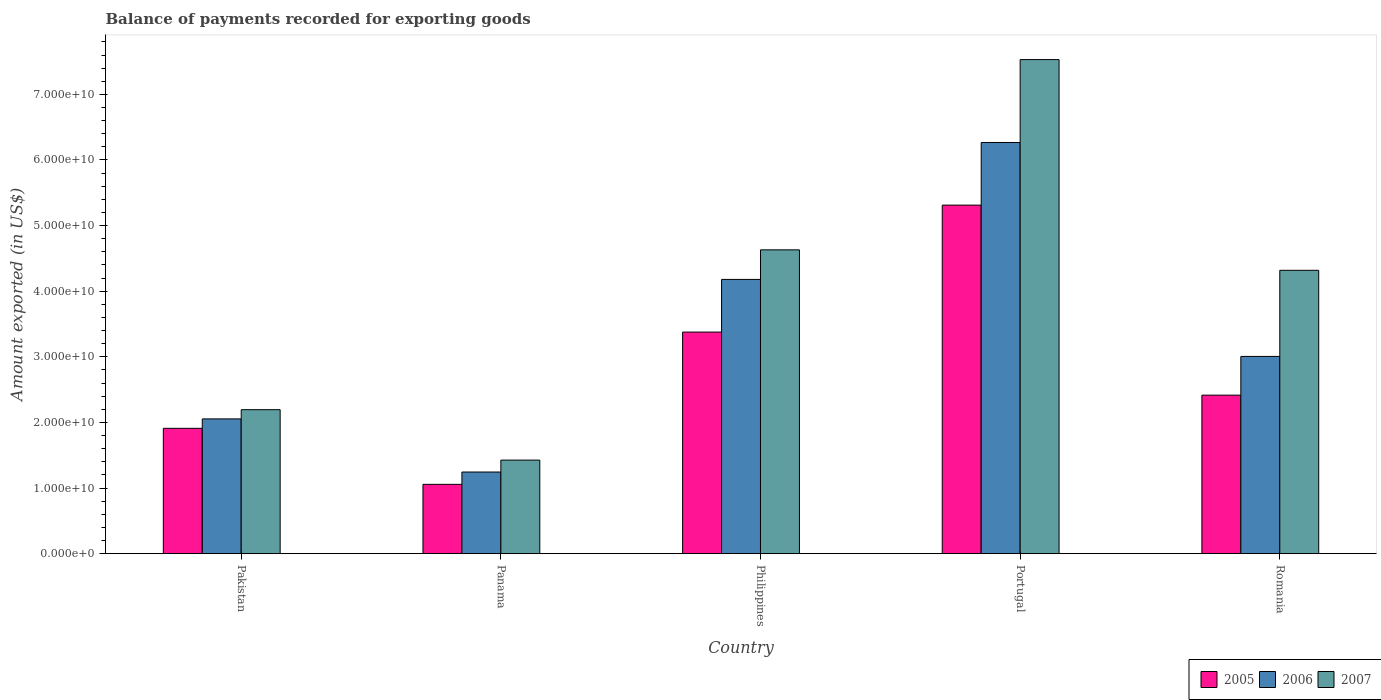How many different coloured bars are there?
Your answer should be very brief. 3. How many groups of bars are there?
Your answer should be compact. 5. Are the number of bars per tick equal to the number of legend labels?
Make the answer very short. Yes. Are the number of bars on each tick of the X-axis equal?
Provide a succinct answer. Yes. What is the label of the 3rd group of bars from the left?
Provide a succinct answer. Philippines. What is the amount exported in 2007 in Romania?
Offer a very short reply. 4.32e+1. Across all countries, what is the maximum amount exported in 2007?
Your answer should be very brief. 7.53e+1. Across all countries, what is the minimum amount exported in 2006?
Provide a short and direct response. 1.24e+1. In which country was the amount exported in 2005 minimum?
Give a very brief answer. Panama. What is the total amount exported in 2006 in the graph?
Your answer should be very brief. 1.68e+11. What is the difference between the amount exported in 2006 in Philippines and that in Portugal?
Your answer should be compact. -2.09e+1. What is the difference between the amount exported in 2006 in Romania and the amount exported in 2007 in Panama?
Your answer should be compact. 1.58e+1. What is the average amount exported in 2005 per country?
Offer a very short reply. 2.81e+1. What is the difference between the amount exported of/in 2005 and amount exported of/in 2007 in Pakistan?
Provide a succinct answer. -2.84e+09. What is the ratio of the amount exported in 2007 in Panama to that in Romania?
Make the answer very short. 0.33. What is the difference between the highest and the second highest amount exported in 2005?
Your answer should be compact. -2.90e+1. What is the difference between the highest and the lowest amount exported in 2007?
Your answer should be very brief. 6.10e+1. Are all the bars in the graph horizontal?
Provide a short and direct response. No. Are the values on the major ticks of Y-axis written in scientific E-notation?
Your answer should be very brief. Yes. Does the graph contain any zero values?
Ensure brevity in your answer.  No. Does the graph contain grids?
Your answer should be compact. No. Where does the legend appear in the graph?
Your response must be concise. Bottom right. How are the legend labels stacked?
Provide a short and direct response. Horizontal. What is the title of the graph?
Keep it short and to the point. Balance of payments recorded for exporting goods. What is the label or title of the X-axis?
Keep it short and to the point. Country. What is the label or title of the Y-axis?
Offer a terse response. Amount exported (in US$). What is the Amount exported (in US$) in 2005 in Pakistan?
Your answer should be compact. 1.91e+1. What is the Amount exported (in US$) of 2006 in Pakistan?
Give a very brief answer. 2.05e+1. What is the Amount exported (in US$) of 2007 in Pakistan?
Give a very brief answer. 2.19e+1. What is the Amount exported (in US$) in 2005 in Panama?
Your response must be concise. 1.06e+1. What is the Amount exported (in US$) in 2006 in Panama?
Keep it short and to the point. 1.24e+1. What is the Amount exported (in US$) of 2007 in Panama?
Provide a short and direct response. 1.43e+1. What is the Amount exported (in US$) of 2005 in Philippines?
Provide a short and direct response. 3.38e+1. What is the Amount exported (in US$) of 2006 in Philippines?
Your answer should be very brief. 4.18e+1. What is the Amount exported (in US$) of 2007 in Philippines?
Your answer should be very brief. 4.63e+1. What is the Amount exported (in US$) of 2005 in Portugal?
Offer a very short reply. 5.31e+1. What is the Amount exported (in US$) in 2006 in Portugal?
Offer a very short reply. 6.27e+1. What is the Amount exported (in US$) of 2007 in Portugal?
Offer a very short reply. 7.53e+1. What is the Amount exported (in US$) in 2005 in Romania?
Provide a succinct answer. 2.42e+1. What is the Amount exported (in US$) in 2006 in Romania?
Offer a very short reply. 3.01e+1. What is the Amount exported (in US$) of 2007 in Romania?
Give a very brief answer. 4.32e+1. Across all countries, what is the maximum Amount exported (in US$) of 2005?
Your response must be concise. 5.31e+1. Across all countries, what is the maximum Amount exported (in US$) of 2006?
Provide a succinct answer. 6.27e+1. Across all countries, what is the maximum Amount exported (in US$) of 2007?
Provide a succinct answer. 7.53e+1. Across all countries, what is the minimum Amount exported (in US$) in 2005?
Offer a terse response. 1.06e+1. Across all countries, what is the minimum Amount exported (in US$) in 2006?
Provide a short and direct response. 1.24e+1. Across all countries, what is the minimum Amount exported (in US$) of 2007?
Your answer should be compact. 1.43e+1. What is the total Amount exported (in US$) of 2005 in the graph?
Give a very brief answer. 1.41e+11. What is the total Amount exported (in US$) of 2006 in the graph?
Give a very brief answer. 1.68e+11. What is the total Amount exported (in US$) of 2007 in the graph?
Your answer should be very brief. 2.01e+11. What is the difference between the Amount exported (in US$) in 2005 in Pakistan and that in Panama?
Ensure brevity in your answer.  8.54e+09. What is the difference between the Amount exported (in US$) in 2006 in Pakistan and that in Panama?
Your answer should be very brief. 8.10e+09. What is the difference between the Amount exported (in US$) of 2007 in Pakistan and that in Panama?
Ensure brevity in your answer.  7.69e+09. What is the difference between the Amount exported (in US$) of 2005 in Pakistan and that in Philippines?
Provide a short and direct response. -1.47e+1. What is the difference between the Amount exported (in US$) in 2006 in Pakistan and that in Philippines?
Give a very brief answer. -2.13e+1. What is the difference between the Amount exported (in US$) in 2007 in Pakistan and that in Philippines?
Make the answer very short. -2.44e+1. What is the difference between the Amount exported (in US$) in 2005 in Pakistan and that in Portugal?
Offer a very short reply. -3.40e+1. What is the difference between the Amount exported (in US$) of 2006 in Pakistan and that in Portugal?
Provide a succinct answer. -4.21e+1. What is the difference between the Amount exported (in US$) in 2007 in Pakistan and that in Portugal?
Provide a short and direct response. -5.34e+1. What is the difference between the Amount exported (in US$) of 2005 in Pakistan and that in Romania?
Give a very brief answer. -5.06e+09. What is the difference between the Amount exported (in US$) of 2006 in Pakistan and that in Romania?
Ensure brevity in your answer.  -9.52e+09. What is the difference between the Amount exported (in US$) of 2007 in Pakistan and that in Romania?
Your answer should be very brief. -2.12e+1. What is the difference between the Amount exported (in US$) in 2005 in Panama and that in Philippines?
Offer a very short reply. -2.32e+1. What is the difference between the Amount exported (in US$) in 2006 in Panama and that in Philippines?
Keep it short and to the point. -2.94e+1. What is the difference between the Amount exported (in US$) in 2007 in Panama and that in Philippines?
Offer a very short reply. -3.20e+1. What is the difference between the Amount exported (in US$) of 2005 in Panama and that in Portugal?
Your response must be concise. -4.26e+1. What is the difference between the Amount exported (in US$) of 2006 in Panama and that in Portugal?
Ensure brevity in your answer.  -5.02e+1. What is the difference between the Amount exported (in US$) in 2007 in Panama and that in Portugal?
Provide a short and direct response. -6.10e+1. What is the difference between the Amount exported (in US$) of 2005 in Panama and that in Romania?
Provide a short and direct response. -1.36e+1. What is the difference between the Amount exported (in US$) of 2006 in Panama and that in Romania?
Your answer should be compact. -1.76e+1. What is the difference between the Amount exported (in US$) of 2007 in Panama and that in Romania?
Keep it short and to the point. -2.89e+1. What is the difference between the Amount exported (in US$) in 2005 in Philippines and that in Portugal?
Your answer should be compact. -1.94e+1. What is the difference between the Amount exported (in US$) of 2006 in Philippines and that in Portugal?
Make the answer very short. -2.09e+1. What is the difference between the Amount exported (in US$) of 2007 in Philippines and that in Portugal?
Your response must be concise. -2.90e+1. What is the difference between the Amount exported (in US$) of 2005 in Philippines and that in Romania?
Your answer should be compact. 9.61e+09. What is the difference between the Amount exported (in US$) of 2006 in Philippines and that in Romania?
Your answer should be very brief. 1.17e+1. What is the difference between the Amount exported (in US$) in 2007 in Philippines and that in Romania?
Your response must be concise. 3.12e+09. What is the difference between the Amount exported (in US$) of 2005 in Portugal and that in Romania?
Provide a succinct answer. 2.90e+1. What is the difference between the Amount exported (in US$) of 2006 in Portugal and that in Romania?
Give a very brief answer. 3.26e+1. What is the difference between the Amount exported (in US$) of 2007 in Portugal and that in Romania?
Make the answer very short. 3.21e+1. What is the difference between the Amount exported (in US$) of 2005 in Pakistan and the Amount exported (in US$) of 2006 in Panama?
Your answer should be compact. 6.66e+09. What is the difference between the Amount exported (in US$) of 2005 in Pakistan and the Amount exported (in US$) of 2007 in Panama?
Make the answer very short. 4.84e+09. What is the difference between the Amount exported (in US$) of 2006 in Pakistan and the Amount exported (in US$) of 2007 in Panama?
Provide a succinct answer. 6.28e+09. What is the difference between the Amount exported (in US$) in 2005 in Pakistan and the Amount exported (in US$) in 2006 in Philippines?
Offer a terse response. -2.27e+1. What is the difference between the Amount exported (in US$) in 2005 in Pakistan and the Amount exported (in US$) in 2007 in Philippines?
Keep it short and to the point. -2.72e+1. What is the difference between the Amount exported (in US$) of 2006 in Pakistan and the Amount exported (in US$) of 2007 in Philippines?
Give a very brief answer. -2.58e+1. What is the difference between the Amount exported (in US$) of 2005 in Pakistan and the Amount exported (in US$) of 2006 in Portugal?
Your answer should be very brief. -4.36e+1. What is the difference between the Amount exported (in US$) in 2005 in Pakistan and the Amount exported (in US$) in 2007 in Portugal?
Offer a very short reply. -5.62e+1. What is the difference between the Amount exported (in US$) in 2006 in Pakistan and the Amount exported (in US$) in 2007 in Portugal?
Give a very brief answer. -5.48e+1. What is the difference between the Amount exported (in US$) in 2005 in Pakistan and the Amount exported (in US$) in 2006 in Romania?
Your response must be concise. -1.10e+1. What is the difference between the Amount exported (in US$) of 2005 in Pakistan and the Amount exported (in US$) of 2007 in Romania?
Offer a terse response. -2.41e+1. What is the difference between the Amount exported (in US$) in 2006 in Pakistan and the Amount exported (in US$) in 2007 in Romania?
Give a very brief answer. -2.26e+1. What is the difference between the Amount exported (in US$) in 2005 in Panama and the Amount exported (in US$) in 2006 in Philippines?
Make the answer very short. -3.12e+1. What is the difference between the Amount exported (in US$) in 2005 in Panama and the Amount exported (in US$) in 2007 in Philippines?
Provide a succinct answer. -3.57e+1. What is the difference between the Amount exported (in US$) in 2006 in Panama and the Amount exported (in US$) in 2007 in Philippines?
Offer a very short reply. -3.39e+1. What is the difference between the Amount exported (in US$) in 2005 in Panama and the Amount exported (in US$) in 2006 in Portugal?
Keep it short and to the point. -5.21e+1. What is the difference between the Amount exported (in US$) in 2005 in Panama and the Amount exported (in US$) in 2007 in Portugal?
Give a very brief answer. -6.47e+1. What is the difference between the Amount exported (in US$) in 2006 in Panama and the Amount exported (in US$) in 2007 in Portugal?
Your response must be concise. -6.29e+1. What is the difference between the Amount exported (in US$) of 2005 in Panama and the Amount exported (in US$) of 2006 in Romania?
Provide a short and direct response. -1.95e+1. What is the difference between the Amount exported (in US$) in 2005 in Panama and the Amount exported (in US$) in 2007 in Romania?
Your answer should be compact. -3.26e+1. What is the difference between the Amount exported (in US$) in 2006 in Panama and the Amount exported (in US$) in 2007 in Romania?
Offer a very short reply. -3.07e+1. What is the difference between the Amount exported (in US$) of 2005 in Philippines and the Amount exported (in US$) of 2006 in Portugal?
Give a very brief answer. -2.89e+1. What is the difference between the Amount exported (in US$) in 2005 in Philippines and the Amount exported (in US$) in 2007 in Portugal?
Ensure brevity in your answer.  -4.15e+1. What is the difference between the Amount exported (in US$) of 2006 in Philippines and the Amount exported (in US$) of 2007 in Portugal?
Ensure brevity in your answer.  -3.35e+1. What is the difference between the Amount exported (in US$) in 2005 in Philippines and the Amount exported (in US$) in 2006 in Romania?
Make the answer very short. 3.71e+09. What is the difference between the Amount exported (in US$) of 2005 in Philippines and the Amount exported (in US$) of 2007 in Romania?
Your response must be concise. -9.42e+09. What is the difference between the Amount exported (in US$) in 2006 in Philippines and the Amount exported (in US$) in 2007 in Romania?
Make the answer very short. -1.39e+09. What is the difference between the Amount exported (in US$) in 2005 in Portugal and the Amount exported (in US$) in 2006 in Romania?
Give a very brief answer. 2.31e+1. What is the difference between the Amount exported (in US$) of 2005 in Portugal and the Amount exported (in US$) of 2007 in Romania?
Ensure brevity in your answer.  9.94e+09. What is the difference between the Amount exported (in US$) of 2006 in Portugal and the Amount exported (in US$) of 2007 in Romania?
Ensure brevity in your answer.  1.95e+1. What is the average Amount exported (in US$) in 2005 per country?
Keep it short and to the point. 2.81e+1. What is the average Amount exported (in US$) in 2006 per country?
Provide a short and direct response. 3.35e+1. What is the average Amount exported (in US$) in 2007 per country?
Provide a succinct answer. 4.02e+1. What is the difference between the Amount exported (in US$) in 2005 and Amount exported (in US$) in 2006 in Pakistan?
Your answer should be very brief. -1.44e+09. What is the difference between the Amount exported (in US$) of 2005 and Amount exported (in US$) of 2007 in Pakistan?
Your answer should be compact. -2.84e+09. What is the difference between the Amount exported (in US$) in 2006 and Amount exported (in US$) in 2007 in Pakistan?
Provide a short and direct response. -1.41e+09. What is the difference between the Amount exported (in US$) in 2005 and Amount exported (in US$) in 2006 in Panama?
Give a very brief answer. -1.88e+09. What is the difference between the Amount exported (in US$) of 2005 and Amount exported (in US$) of 2007 in Panama?
Give a very brief answer. -3.70e+09. What is the difference between the Amount exported (in US$) of 2006 and Amount exported (in US$) of 2007 in Panama?
Ensure brevity in your answer.  -1.82e+09. What is the difference between the Amount exported (in US$) in 2005 and Amount exported (in US$) in 2006 in Philippines?
Ensure brevity in your answer.  -8.03e+09. What is the difference between the Amount exported (in US$) in 2005 and Amount exported (in US$) in 2007 in Philippines?
Your answer should be very brief. -1.25e+1. What is the difference between the Amount exported (in US$) in 2006 and Amount exported (in US$) in 2007 in Philippines?
Your answer should be compact. -4.51e+09. What is the difference between the Amount exported (in US$) in 2005 and Amount exported (in US$) in 2006 in Portugal?
Your response must be concise. -9.54e+09. What is the difference between the Amount exported (in US$) of 2005 and Amount exported (in US$) of 2007 in Portugal?
Your answer should be very brief. -2.22e+1. What is the difference between the Amount exported (in US$) of 2006 and Amount exported (in US$) of 2007 in Portugal?
Provide a short and direct response. -1.26e+1. What is the difference between the Amount exported (in US$) in 2005 and Amount exported (in US$) in 2006 in Romania?
Your response must be concise. -5.90e+09. What is the difference between the Amount exported (in US$) of 2005 and Amount exported (in US$) of 2007 in Romania?
Offer a very short reply. -1.90e+1. What is the difference between the Amount exported (in US$) of 2006 and Amount exported (in US$) of 2007 in Romania?
Your response must be concise. -1.31e+1. What is the ratio of the Amount exported (in US$) in 2005 in Pakistan to that in Panama?
Give a very brief answer. 1.81. What is the ratio of the Amount exported (in US$) in 2006 in Pakistan to that in Panama?
Ensure brevity in your answer.  1.65. What is the ratio of the Amount exported (in US$) of 2007 in Pakistan to that in Panama?
Offer a very short reply. 1.54. What is the ratio of the Amount exported (in US$) of 2005 in Pakistan to that in Philippines?
Your answer should be very brief. 0.57. What is the ratio of the Amount exported (in US$) of 2006 in Pakistan to that in Philippines?
Ensure brevity in your answer.  0.49. What is the ratio of the Amount exported (in US$) in 2007 in Pakistan to that in Philippines?
Give a very brief answer. 0.47. What is the ratio of the Amount exported (in US$) in 2005 in Pakistan to that in Portugal?
Your answer should be compact. 0.36. What is the ratio of the Amount exported (in US$) in 2006 in Pakistan to that in Portugal?
Offer a very short reply. 0.33. What is the ratio of the Amount exported (in US$) of 2007 in Pakistan to that in Portugal?
Ensure brevity in your answer.  0.29. What is the ratio of the Amount exported (in US$) of 2005 in Pakistan to that in Romania?
Your answer should be very brief. 0.79. What is the ratio of the Amount exported (in US$) in 2006 in Pakistan to that in Romania?
Provide a succinct answer. 0.68. What is the ratio of the Amount exported (in US$) of 2007 in Pakistan to that in Romania?
Your answer should be very brief. 0.51. What is the ratio of the Amount exported (in US$) in 2005 in Panama to that in Philippines?
Provide a short and direct response. 0.31. What is the ratio of the Amount exported (in US$) of 2006 in Panama to that in Philippines?
Give a very brief answer. 0.3. What is the ratio of the Amount exported (in US$) in 2007 in Panama to that in Philippines?
Ensure brevity in your answer.  0.31. What is the ratio of the Amount exported (in US$) of 2005 in Panama to that in Portugal?
Make the answer very short. 0.2. What is the ratio of the Amount exported (in US$) of 2006 in Panama to that in Portugal?
Make the answer very short. 0.2. What is the ratio of the Amount exported (in US$) in 2007 in Panama to that in Portugal?
Make the answer very short. 0.19. What is the ratio of the Amount exported (in US$) in 2005 in Panama to that in Romania?
Offer a very short reply. 0.44. What is the ratio of the Amount exported (in US$) of 2006 in Panama to that in Romania?
Give a very brief answer. 0.41. What is the ratio of the Amount exported (in US$) of 2007 in Panama to that in Romania?
Your response must be concise. 0.33. What is the ratio of the Amount exported (in US$) of 2005 in Philippines to that in Portugal?
Offer a terse response. 0.64. What is the ratio of the Amount exported (in US$) of 2006 in Philippines to that in Portugal?
Provide a short and direct response. 0.67. What is the ratio of the Amount exported (in US$) in 2007 in Philippines to that in Portugal?
Offer a very short reply. 0.61. What is the ratio of the Amount exported (in US$) in 2005 in Philippines to that in Romania?
Provide a short and direct response. 1.4. What is the ratio of the Amount exported (in US$) in 2006 in Philippines to that in Romania?
Offer a very short reply. 1.39. What is the ratio of the Amount exported (in US$) in 2007 in Philippines to that in Romania?
Offer a terse response. 1.07. What is the ratio of the Amount exported (in US$) in 2005 in Portugal to that in Romania?
Ensure brevity in your answer.  2.2. What is the ratio of the Amount exported (in US$) in 2006 in Portugal to that in Romania?
Make the answer very short. 2.08. What is the ratio of the Amount exported (in US$) of 2007 in Portugal to that in Romania?
Your response must be concise. 1.74. What is the difference between the highest and the second highest Amount exported (in US$) of 2005?
Make the answer very short. 1.94e+1. What is the difference between the highest and the second highest Amount exported (in US$) in 2006?
Your answer should be very brief. 2.09e+1. What is the difference between the highest and the second highest Amount exported (in US$) in 2007?
Your answer should be compact. 2.90e+1. What is the difference between the highest and the lowest Amount exported (in US$) of 2005?
Your answer should be compact. 4.26e+1. What is the difference between the highest and the lowest Amount exported (in US$) of 2006?
Your answer should be compact. 5.02e+1. What is the difference between the highest and the lowest Amount exported (in US$) in 2007?
Make the answer very short. 6.10e+1. 